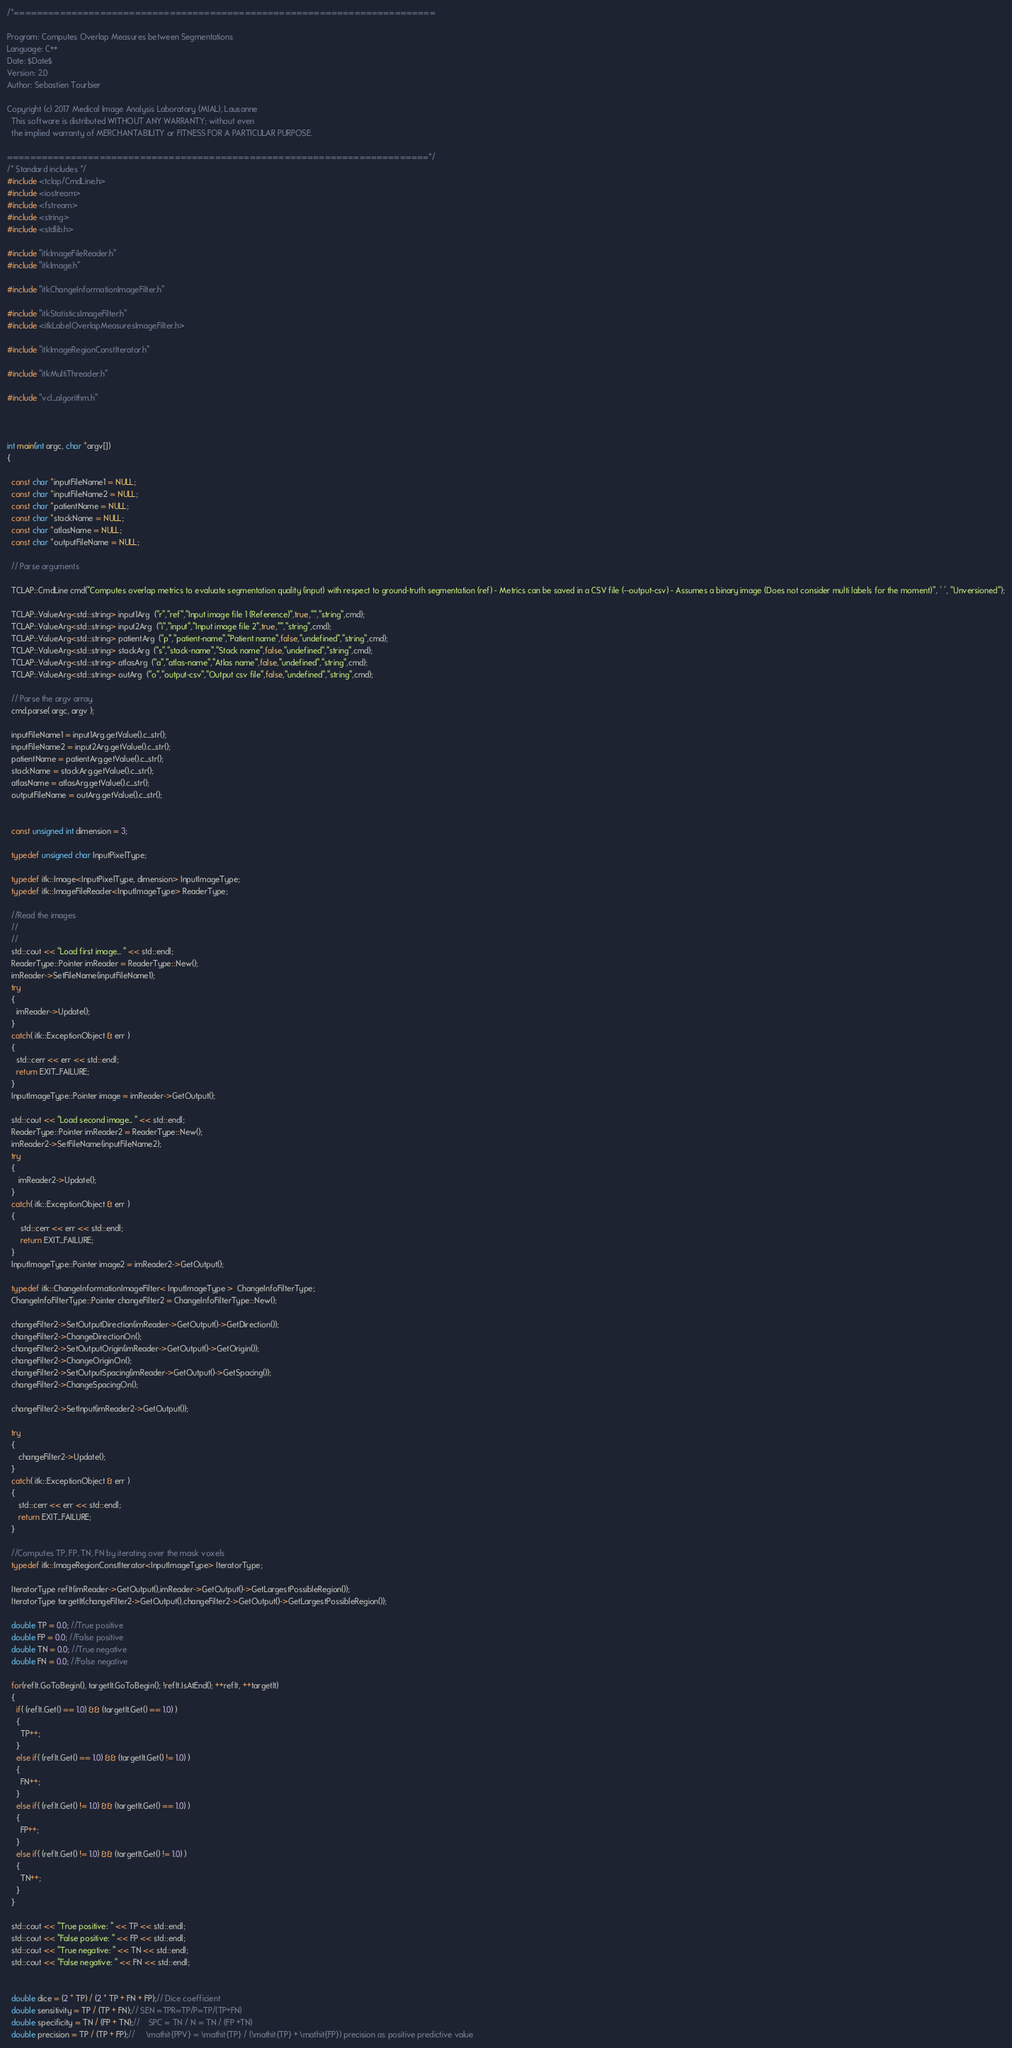Convert code to text. <code><loc_0><loc_0><loc_500><loc_500><_C++_>/*=========================================================================

Program: Computes Overlap Measures between Segmentations
Language: C++
Date: $Date$
Version: 2.0
Author: Sebastien Tourbier

Copyright (c) 2017 Medical Image Analysis Laboratory (MIAL), Lausanne
  This software is distributed WITHOUT ANY WARRANTY; without even
  the implied warranty of MERCHANTABILITY or FITNESS FOR A PARTICULAR PURPOSE.
     
=========================================================================*/
/* Standard includes */
#include <tclap/CmdLine.h>
#include <iostream>
#include <fstream>
#include <string>
#include <stdlib.h>

#include "itkImageFileReader.h"
#include "itkImage.h"

#include "itkChangeInformationImageFilter.h"

#include "itkStatisticsImageFilter.h"
#include <itkLabelOverlapMeasuresImageFilter.h>

#include "itkImageRegionConstIterator.h"

#include "itkMultiThreader.h"

#include "vcl_algorithm.h"



int main(int argc, char *argv[])
{

  const char *inputFileName1 = NULL;
  const char *inputFileName2 = NULL;
  const char *patientName = NULL;
  const char *stackName = NULL;
  const char *atlasName = NULL;
  const char *outputFileName = NULL;

  // Parse arguments

  TCLAP::CmdLine cmd("Computes overlap metrics to evaluate segmentation quality (input) with respect to ground-truth segmentation (ref) - Metrics can be saved in a CSV file (--output-csv) - Assumes a binary image (Does not consider multi labels for the moment)", ' ', "Unversioned");

  TCLAP::ValueArg<std::string> input1Arg  ("r","ref","Input image file 1 (Reference)",true,"","string",cmd);
  TCLAP::ValueArg<std::string> input2Arg  ("i","input","Input image file 2",true,"","string",cmd);
  TCLAP::ValueArg<std::string> patientArg  ("p","patient-name","Patient name",false,"undefined","string",cmd);
  TCLAP::ValueArg<std::string> stackArg  ("s","stack-name","Stack name",false,"undefined","string",cmd);
  TCLAP::ValueArg<std::string> atlasArg  ("a","atlas-name","Atlas name",false,"undefined","string",cmd);
  TCLAP::ValueArg<std::string> outArg  ("o","output-csv","Output csv file",false,"undefined","string",cmd);

  // Parse the argv array.
  cmd.parse( argc, argv );

  inputFileName1 = input1Arg.getValue().c_str();
  inputFileName2 = input2Arg.getValue().c_str();
  patientName = patientArg.getValue().c_str();
  stackName = stackArg.getValue().c_str();
  atlasName = atlasArg.getValue().c_str();
  outputFileName = outArg.getValue().c_str();

 
  const unsigned int dimension = 3; 
  
  typedef unsigned char InputPixelType;

  typedef itk::Image<InputPixelType, dimension> InputImageType;
  typedef itk::ImageFileReader<InputImageType> ReaderType;

  //Read the images 
  //
  //
  std::cout << "Load first image... " << std::endl;
  ReaderType::Pointer imReader = ReaderType::New();
  imReader->SetFileName(inputFileName1);
  try
  {
    imReader->Update();
  }
  catch( itk::ExceptionObject & err )
  {
    std::cerr << err << std::endl;
    return EXIT_FAILURE;
  }
  InputImageType::Pointer image = imReader->GetOutput();
   
  std::cout << "Load second image... " << std::endl;
  ReaderType::Pointer imReader2 = ReaderType::New();
  imReader2->SetFileName(inputFileName2);
  try
  {
     imReader2->Update();
  }
  catch( itk::ExceptionObject & err )
  {
      std::cerr << err << std::endl;
      return EXIT_FAILURE;
  }
  InputImageType::Pointer image2 = imReader2->GetOutput();
  
  typedef itk::ChangeInformationImageFilter< InputImageType >  ChangeInfoFilterType;
  ChangeInfoFilterType::Pointer changeFilter2 = ChangeInfoFilterType::New();
  
  changeFilter2->SetOutputDirection(imReader->GetOutput()->GetDirection());
  changeFilter2->ChangeDirectionOn();
  changeFilter2->SetOutputOrigin(imReader->GetOutput()->GetOrigin());
  changeFilter2->ChangeOriginOn();
  changeFilter2->SetOutputSpacing(imReader->GetOutput()->GetSpacing());
  changeFilter2->ChangeSpacingOn();
  
  changeFilter2->SetInput(imReader2->GetOutput());
  
  try
  {
     changeFilter2->Update();
  }
  catch( itk::ExceptionObject & err )
  {
     std::cerr << err << std::endl;
     return EXIT_FAILURE;
  }

  //Computes TP, FP, TN, FN by iterating over the mask voxels
  typedef itk::ImageRegionConstIterator<InputImageType> IteratorType;
  
  IteratorType refIt(imReader->GetOutput(),imReader->GetOutput()->GetLargestPossibleRegion());
  IteratorType targetIt(changeFilter2->GetOutput(),changeFilter2->GetOutput()->GetLargestPossibleRegion());

  double TP = 0.0; //True positive
  double FP = 0.0; //False positive
  double TN = 0.0; //True negative
  double FN = 0.0; //False negative

  for(refIt.GoToBegin(), targetIt.GoToBegin(); !refIt.IsAtEnd(); ++refIt, ++targetIt)
  {
    if( (refIt.Get() == 1.0) && (targetIt.Get() == 1.0) )
    {
      TP++;
    }
    else if( (refIt.Get() == 1.0) && (targetIt.Get() != 1.0) )
    {
      FN++;
    }
    else if( (refIt.Get() != 1.0) && (targetIt.Get() == 1.0) )
    {
      FP++;
    }
    else if( (refIt.Get() != 1.0) && (targetIt.Get() != 1.0) )
    {
      TN++;
    }
  }

  std::cout << "True positive: " << TP << std::endl;
  std::cout << "False positive: " << FP << std::endl;
  std::cout << "True negative: " << TN << std::endl;
  std::cout << "False negative: " << FN << std::endl;


  double dice = (2 * TP) / (2 * TP + FN + FP);// Dice coefficient
  double sensitivity = TP / (TP + FN);// SEN =TPR=TP/P=TP/(TP+FN)
  double specificity = TN / (FP + TN);//    SPC = TN / N = TN / (FP +TN)
  double precision = TP / (TP + FP);//     \mathit{PPV} = \mathit{TP} / (\mathit{TP} + \mathit{FP}) precision as positive predictive value</code> 